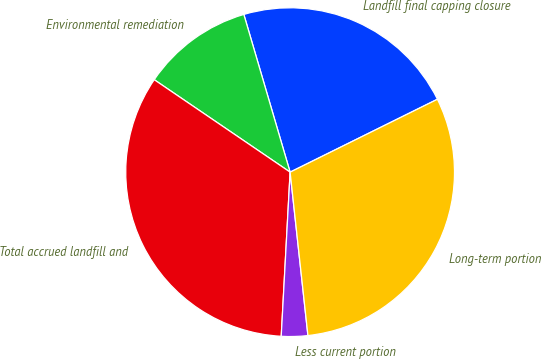Convert chart. <chart><loc_0><loc_0><loc_500><loc_500><pie_chart><fcel>Landfill final capping closure<fcel>Environmental remediation<fcel>Total accrued landfill and<fcel>Less current portion<fcel>Long-term portion<nl><fcel>22.23%<fcel>10.95%<fcel>33.65%<fcel>2.59%<fcel>30.59%<nl></chart> 